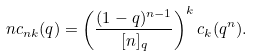<formula> <loc_0><loc_0><loc_500><loc_500>n c _ { n k } ( q ) = \left ( \frac { ( 1 - q ) ^ { n - 1 } } { [ n ] _ { q } } \right ) ^ { k } c _ { k } ( q ^ { n } ) .</formula> 